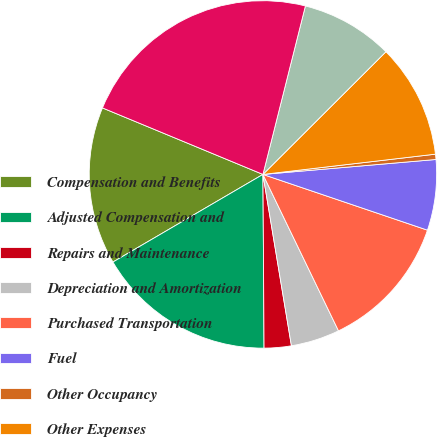Convert chart. <chart><loc_0><loc_0><loc_500><loc_500><pie_chart><fcel>Compensation and Benefits<fcel>Adjusted Compensation and<fcel>Repairs and Maintenance<fcel>Depreciation and Amortization<fcel>Purchased Transportation<fcel>Fuel<fcel>Other Occupancy<fcel>Other Expenses<fcel>Adjusted Other Expenses<fcel>Total Operating Expenses<nl><fcel>14.67%<fcel>16.69%<fcel>2.52%<fcel>4.54%<fcel>12.64%<fcel>6.57%<fcel>0.49%<fcel>10.62%<fcel>8.59%<fcel>22.68%<nl></chart> 